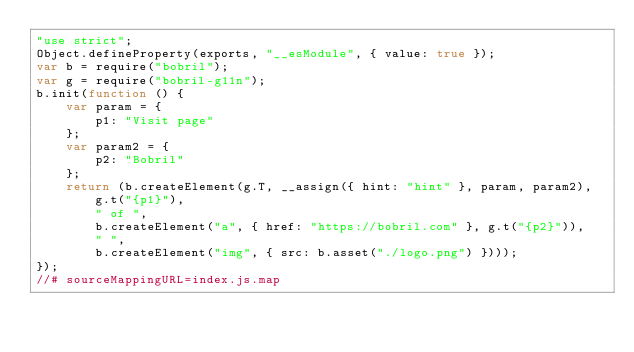<code> <loc_0><loc_0><loc_500><loc_500><_JavaScript_>"use strict";
Object.defineProperty(exports, "__esModule", { value: true });
var b = require("bobril");
var g = require("bobril-g11n");
b.init(function () {
    var param = {
        p1: "Visit page"
    };
    var param2 = {
        p2: "Bobril"
    };
    return (b.createElement(g.T, __assign({ hint: "hint" }, param, param2),
        g.t("{p1}"),
        " of ",
        b.createElement("a", { href: "https://bobril.com" }, g.t("{p2}")),
        " ",
        b.createElement("img", { src: b.asset("./logo.png") })));
});
//# sourceMappingURL=index.js.map</code> 